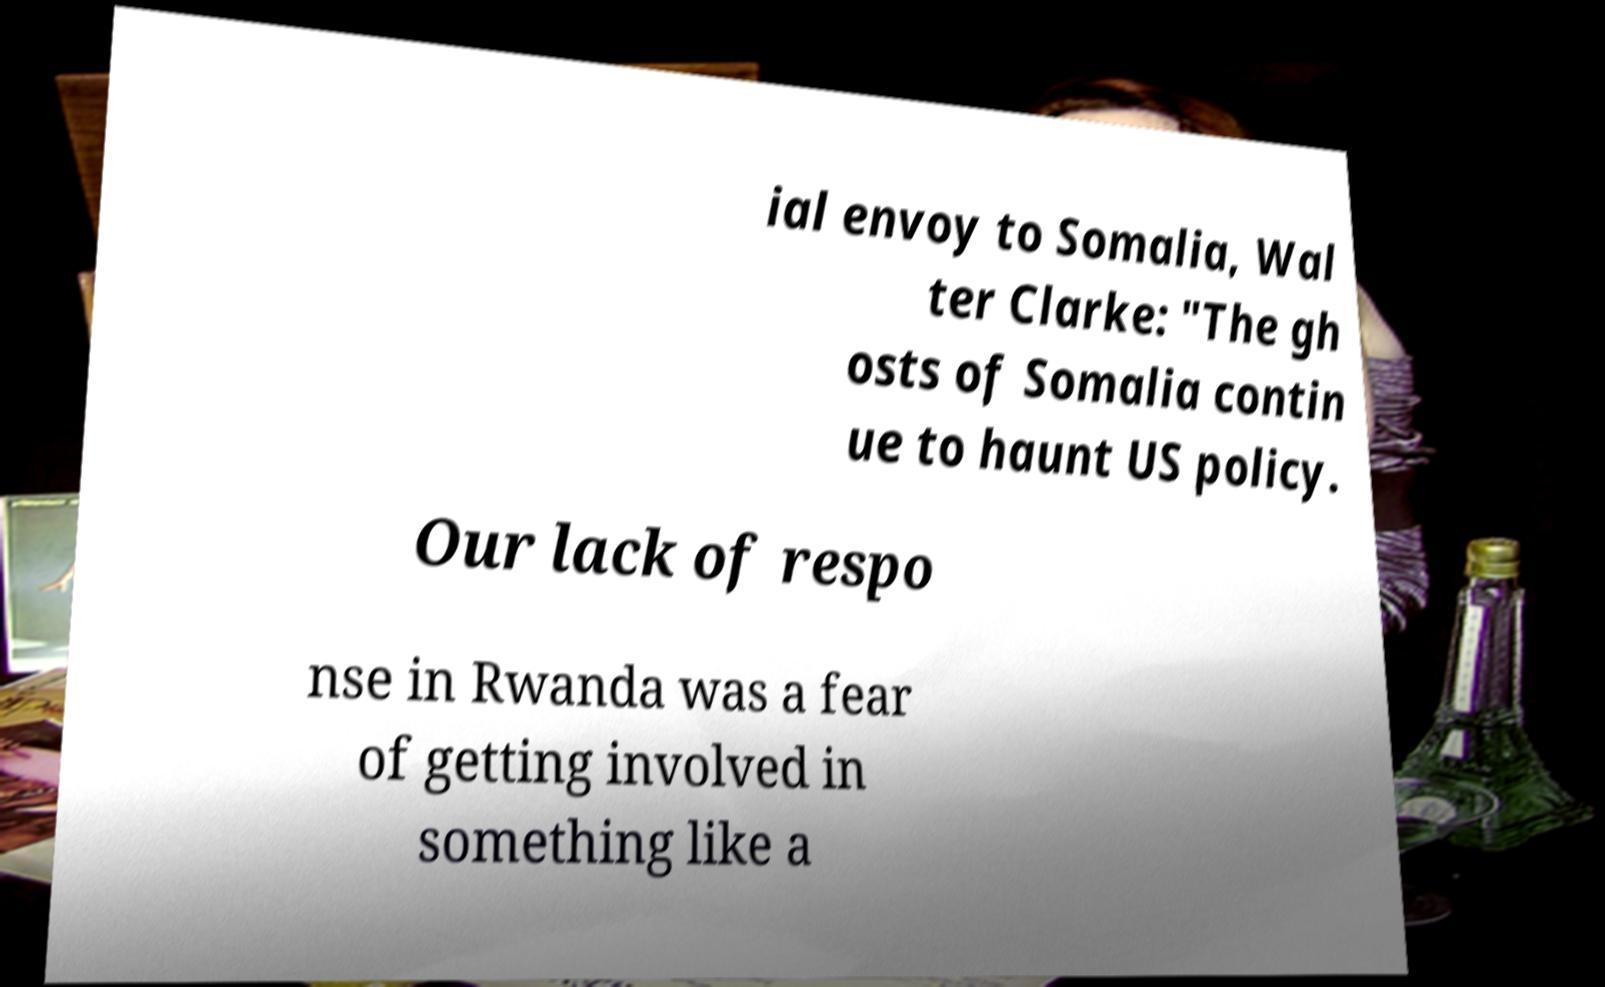Please read and relay the text visible in this image. What does it say? ial envoy to Somalia, Wal ter Clarke: "The gh osts of Somalia contin ue to haunt US policy. Our lack of respo nse in Rwanda was a fear of getting involved in something like a 